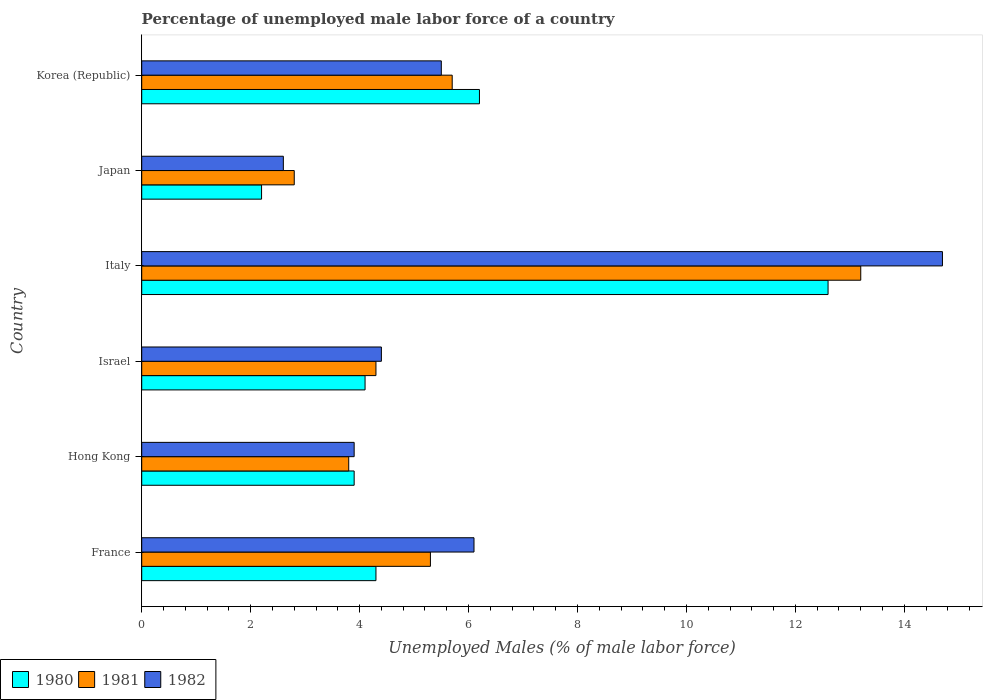How many groups of bars are there?
Offer a terse response. 6. Are the number of bars per tick equal to the number of legend labels?
Your answer should be compact. Yes. Are the number of bars on each tick of the Y-axis equal?
Provide a succinct answer. Yes. How many bars are there on the 5th tick from the top?
Make the answer very short. 3. How many bars are there on the 4th tick from the bottom?
Provide a succinct answer. 3. What is the percentage of unemployed male labor force in 1982 in Hong Kong?
Provide a succinct answer. 3.9. Across all countries, what is the maximum percentage of unemployed male labor force in 1981?
Provide a succinct answer. 13.2. Across all countries, what is the minimum percentage of unemployed male labor force in 1982?
Give a very brief answer. 2.6. In which country was the percentage of unemployed male labor force in 1981 maximum?
Provide a short and direct response. Italy. In which country was the percentage of unemployed male labor force in 1982 minimum?
Give a very brief answer. Japan. What is the total percentage of unemployed male labor force in 1980 in the graph?
Keep it short and to the point. 33.3. What is the difference between the percentage of unemployed male labor force in 1981 in Hong Kong and that in Japan?
Give a very brief answer. 1. What is the difference between the percentage of unemployed male labor force in 1982 in Israel and the percentage of unemployed male labor force in 1980 in Japan?
Offer a terse response. 2.2. What is the average percentage of unemployed male labor force in 1982 per country?
Ensure brevity in your answer.  6.2. What is the difference between the percentage of unemployed male labor force in 1980 and percentage of unemployed male labor force in 1981 in Hong Kong?
Your response must be concise. 0.1. What is the ratio of the percentage of unemployed male labor force in 1981 in Hong Kong to that in Italy?
Provide a succinct answer. 0.29. Is the percentage of unemployed male labor force in 1981 in Israel less than that in Italy?
Keep it short and to the point. Yes. Is the difference between the percentage of unemployed male labor force in 1980 in Hong Kong and Italy greater than the difference between the percentage of unemployed male labor force in 1981 in Hong Kong and Italy?
Your answer should be very brief. Yes. What is the difference between the highest and the second highest percentage of unemployed male labor force in 1980?
Keep it short and to the point. 6.4. What is the difference between the highest and the lowest percentage of unemployed male labor force in 1980?
Ensure brevity in your answer.  10.4. In how many countries, is the percentage of unemployed male labor force in 1980 greater than the average percentage of unemployed male labor force in 1980 taken over all countries?
Give a very brief answer. 2. Is the sum of the percentage of unemployed male labor force in 1981 in France and Israel greater than the maximum percentage of unemployed male labor force in 1982 across all countries?
Provide a short and direct response. No. What does the 1st bar from the bottom in Italy represents?
Your answer should be very brief. 1980. How many bars are there?
Ensure brevity in your answer.  18. What is the difference between two consecutive major ticks on the X-axis?
Keep it short and to the point. 2. Are the values on the major ticks of X-axis written in scientific E-notation?
Give a very brief answer. No. Does the graph contain any zero values?
Keep it short and to the point. No. Where does the legend appear in the graph?
Provide a short and direct response. Bottom left. What is the title of the graph?
Provide a succinct answer. Percentage of unemployed male labor force of a country. Does "1975" appear as one of the legend labels in the graph?
Ensure brevity in your answer.  No. What is the label or title of the X-axis?
Provide a succinct answer. Unemployed Males (% of male labor force). What is the Unemployed Males (% of male labor force) in 1980 in France?
Offer a terse response. 4.3. What is the Unemployed Males (% of male labor force) of 1981 in France?
Provide a succinct answer. 5.3. What is the Unemployed Males (% of male labor force) in 1982 in France?
Keep it short and to the point. 6.1. What is the Unemployed Males (% of male labor force) of 1980 in Hong Kong?
Your answer should be compact. 3.9. What is the Unemployed Males (% of male labor force) in 1981 in Hong Kong?
Ensure brevity in your answer.  3.8. What is the Unemployed Males (% of male labor force) of 1982 in Hong Kong?
Keep it short and to the point. 3.9. What is the Unemployed Males (% of male labor force) of 1980 in Israel?
Provide a short and direct response. 4.1. What is the Unemployed Males (% of male labor force) in 1981 in Israel?
Your answer should be compact. 4.3. What is the Unemployed Males (% of male labor force) of 1982 in Israel?
Offer a very short reply. 4.4. What is the Unemployed Males (% of male labor force) of 1980 in Italy?
Your answer should be compact. 12.6. What is the Unemployed Males (% of male labor force) of 1981 in Italy?
Provide a succinct answer. 13.2. What is the Unemployed Males (% of male labor force) of 1982 in Italy?
Provide a short and direct response. 14.7. What is the Unemployed Males (% of male labor force) in 1980 in Japan?
Your response must be concise. 2.2. What is the Unemployed Males (% of male labor force) of 1981 in Japan?
Your response must be concise. 2.8. What is the Unemployed Males (% of male labor force) in 1982 in Japan?
Provide a short and direct response. 2.6. What is the Unemployed Males (% of male labor force) of 1980 in Korea (Republic)?
Ensure brevity in your answer.  6.2. What is the Unemployed Males (% of male labor force) of 1981 in Korea (Republic)?
Keep it short and to the point. 5.7. What is the Unemployed Males (% of male labor force) in 1982 in Korea (Republic)?
Ensure brevity in your answer.  5.5. Across all countries, what is the maximum Unemployed Males (% of male labor force) of 1980?
Keep it short and to the point. 12.6. Across all countries, what is the maximum Unemployed Males (% of male labor force) in 1981?
Your answer should be compact. 13.2. Across all countries, what is the maximum Unemployed Males (% of male labor force) of 1982?
Your answer should be compact. 14.7. Across all countries, what is the minimum Unemployed Males (% of male labor force) in 1980?
Provide a short and direct response. 2.2. Across all countries, what is the minimum Unemployed Males (% of male labor force) of 1981?
Your answer should be compact. 2.8. Across all countries, what is the minimum Unemployed Males (% of male labor force) in 1982?
Give a very brief answer. 2.6. What is the total Unemployed Males (% of male labor force) of 1980 in the graph?
Ensure brevity in your answer.  33.3. What is the total Unemployed Males (% of male labor force) of 1981 in the graph?
Offer a terse response. 35.1. What is the total Unemployed Males (% of male labor force) of 1982 in the graph?
Your answer should be compact. 37.2. What is the difference between the Unemployed Males (% of male labor force) in 1981 in France and that in Israel?
Your answer should be very brief. 1. What is the difference between the Unemployed Males (% of male labor force) in 1982 in France and that in Israel?
Provide a succinct answer. 1.7. What is the difference between the Unemployed Males (% of male labor force) in 1980 in France and that in Italy?
Your response must be concise. -8.3. What is the difference between the Unemployed Males (% of male labor force) of 1980 in France and that in Japan?
Ensure brevity in your answer.  2.1. What is the difference between the Unemployed Males (% of male labor force) of 1982 in France and that in Korea (Republic)?
Offer a terse response. 0.6. What is the difference between the Unemployed Males (% of male labor force) in 1981 in Hong Kong and that in Israel?
Your answer should be compact. -0.5. What is the difference between the Unemployed Males (% of male labor force) of 1982 in Hong Kong and that in Italy?
Offer a terse response. -10.8. What is the difference between the Unemployed Males (% of male labor force) in 1980 in Hong Kong and that in Japan?
Make the answer very short. 1.7. What is the difference between the Unemployed Males (% of male labor force) of 1981 in Hong Kong and that in Japan?
Ensure brevity in your answer.  1. What is the difference between the Unemployed Males (% of male labor force) in 1982 in Hong Kong and that in Japan?
Offer a terse response. 1.3. What is the difference between the Unemployed Males (% of male labor force) in 1980 in Hong Kong and that in Korea (Republic)?
Provide a short and direct response. -2.3. What is the difference between the Unemployed Males (% of male labor force) in 1980 in Israel and that in Italy?
Your answer should be compact. -8.5. What is the difference between the Unemployed Males (% of male labor force) of 1981 in Israel and that in Italy?
Ensure brevity in your answer.  -8.9. What is the difference between the Unemployed Males (% of male labor force) of 1982 in Israel and that in Japan?
Keep it short and to the point. 1.8. What is the difference between the Unemployed Males (% of male labor force) in 1982 in Israel and that in Korea (Republic)?
Your response must be concise. -1.1. What is the difference between the Unemployed Males (% of male labor force) of 1982 in Italy and that in Japan?
Your answer should be compact. 12.1. What is the difference between the Unemployed Males (% of male labor force) of 1980 in Italy and that in Korea (Republic)?
Provide a short and direct response. 6.4. What is the difference between the Unemployed Males (% of male labor force) in 1982 in Italy and that in Korea (Republic)?
Offer a very short reply. 9.2. What is the difference between the Unemployed Males (% of male labor force) of 1981 in Japan and that in Korea (Republic)?
Provide a succinct answer. -2.9. What is the difference between the Unemployed Males (% of male labor force) of 1980 in France and the Unemployed Males (% of male labor force) of 1982 in Hong Kong?
Your response must be concise. 0.4. What is the difference between the Unemployed Males (% of male labor force) in 1980 in France and the Unemployed Males (% of male labor force) in 1981 in Israel?
Make the answer very short. 0. What is the difference between the Unemployed Males (% of male labor force) in 1981 in France and the Unemployed Males (% of male labor force) in 1982 in Israel?
Your answer should be compact. 0.9. What is the difference between the Unemployed Males (% of male labor force) in 1980 in France and the Unemployed Males (% of male labor force) in 1981 in Italy?
Ensure brevity in your answer.  -8.9. What is the difference between the Unemployed Males (% of male labor force) of 1981 in France and the Unemployed Males (% of male labor force) of 1982 in Italy?
Make the answer very short. -9.4. What is the difference between the Unemployed Males (% of male labor force) of 1980 in France and the Unemployed Males (% of male labor force) of 1982 in Japan?
Keep it short and to the point. 1.7. What is the difference between the Unemployed Males (% of male labor force) of 1981 in France and the Unemployed Males (% of male labor force) of 1982 in Japan?
Ensure brevity in your answer.  2.7. What is the difference between the Unemployed Males (% of male labor force) in 1980 in France and the Unemployed Males (% of male labor force) in 1982 in Korea (Republic)?
Give a very brief answer. -1.2. What is the difference between the Unemployed Males (% of male labor force) of 1981 in France and the Unemployed Males (% of male labor force) of 1982 in Korea (Republic)?
Your answer should be compact. -0.2. What is the difference between the Unemployed Males (% of male labor force) of 1980 in Hong Kong and the Unemployed Males (% of male labor force) of 1981 in Israel?
Offer a terse response. -0.4. What is the difference between the Unemployed Males (% of male labor force) in 1980 in Hong Kong and the Unemployed Males (% of male labor force) in 1981 in Italy?
Give a very brief answer. -9.3. What is the difference between the Unemployed Males (% of male labor force) of 1980 in Hong Kong and the Unemployed Males (% of male labor force) of 1982 in Italy?
Give a very brief answer. -10.8. What is the difference between the Unemployed Males (% of male labor force) in 1981 in Hong Kong and the Unemployed Males (% of male labor force) in 1982 in Italy?
Offer a very short reply. -10.9. What is the difference between the Unemployed Males (% of male labor force) of 1980 in Hong Kong and the Unemployed Males (% of male labor force) of 1982 in Japan?
Offer a very short reply. 1.3. What is the difference between the Unemployed Males (% of male labor force) in 1981 in Hong Kong and the Unemployed Males (% of male labor force) in 1982 in Japan?
Offer a terse response. 1.2. What is the difference between the Unemployed Males (% of male labor force) of 1980 in Hong Kong and the Unemployed Males (% of male labor force) of 1981 in Korea (Republic)?
Offer a very short reply. -1.8. What is the difference between the Unemployed Males (% of male labor force) in 1980 in Israel and the Unemployed Males (% of male labor force) in 1981 in Italy?
Keep it short and to the point. -9.1. What is the difference between the Unemployed Males (% of male labor force) of 1980 in Israel and the Unemployed Males (% of male labor force) of 1981 in Japan?
Your response must be concise. 1.3. What is the difference between the Unemployed Males (% of male labor force) of 1981 in Israel and the Unemployed Males (% of male labor force) of 1982 in Japan?
Your answer should be very brief. 1.7. What is the difference between the Unemployed Males (% of male labor force) of 1980 in Israel and the Unemployed Males (% of male labor force) of 1981 in Korea (Republic)?
Give a very brief answer. -1.6. What is the difference between the Unemployed Males (% of male labor force) of 1981 in Italy and the Unemployed Males (% of male labor force) of 1982 in Japan?
Give a very brief answer. 10.6. What is the difference between the Unemployed Males (% of male labor force) in 1980 in Italy and the Unemployed Males (% of male labor force) in 1982 in Korea (Republic)?
Keep it short and to the point. 7.1. What is the difference between the Unemployed Males (% of male labor force) of 1981 in Italy and the Unemployed Males (% of male labor force) of 1982 in Korea (Republic)?
Give a very brief answer. 7.7. What is the difference between the Unemployed Males (% of male labor force) in 1980 in Japan and the Unemployed Males (% of male labor force) in 1982 in Korea (Republic)?
Ensure brevity in your answer.  -3.3. What is the average Unemployed Males (% of male labor force) in 1980 per country?
Offer a terse response. 5.55. What is the average Unemployed Males (% of male labor force) of 1981 per country?
Your answer should be compact. 5.85. What is the average Unemployed Males (% of male labor force) of 1982 per country?
Provide a short and direct response. 6.2. What is the difference between the Unemployed Males (% of male labor force) in 1981 and Unemployed Males (% of male labor force) in 1982 in France?
Provide a short and direct response. -0.8. What is the difference between the Unemployed Males (% of male labor force) of 1980 and Unemployed Males (% of male labor force) of 1981 in Hong Kong?
Offer a very short reply. 0.1. What is the difference between the Unemployed Males (% of male labor force) of 1980 and Unemployed Males (% of male labor force) of 1981 in Israel?
Keep it short and to the point. -0.2. What is the difference between the Unemployed Males (% of male labor force) of 1981 and Unemployed Males (% of male labor force) of 1982 in Israel?
Keep it short and to the point. -0.1. What is the difference between the Unemployed Males (% of male labor force) of 1980 and Unemployed Males (% of male labor force) of 1981 in Italy?
Your answer should be very brief. -0.6. What is the difference between the Unemployed Males (% of male labor force) of 1980 and Unemployed Males (% of male labor force) of 1982 in Italy?
Give a very brief answer. -2.1. What is the difference between the Unemployed Males (% of male labor force) of 1980 and Unemployed Males (% of male labor force) of 1981 in Japan?
Offer a very short reply. -0.6. What is the difference between the Unemployed Males (% of male labor force) in 1980 and Unemployed Males (% of male labor force) in 1982 in Japan?
Ensure brevity in your answer.  -0.4. What is the difference between the Unemployed Males (% of male labor force) in 1981 and Unemployed Males (% of male labor force) in 1982 in Japan?
Provide a short and direct response. 0.2. What is the difference between the Unemployed Males (% of male labor force) of 1980 and Unemployed Males (% of male labor force) of 1982 in Korea (Republic)?
Ensure brevity in your answer.  0.7. What is the ratio of the Unemployed Males (% of male labor force) of 1980 in France to that in Hong Kong?
Give a very brief answer. 1.1. What is the ratio of the Unemployed Males (% of male labor force) in 1981 in France to that in Hong Kong?
Your answer should be compact. 1.39. What is the ratio of the Unemployed Males (% of male labor force) in 1982 in France to that in Hong Kong?
Offer a very short reply. 1.56. What is the ratio of the Unemployed Males (% of male labor force) of 1980 in France to that in Israel?
Give a very brief answer. 1.05. What is the ratio of the Unemployed Males (% of male labor force) in 1981 in France to that in Israel?
Provide a short and direct response. 1.23. What is the ratio of the Unemployed Males (% of male labor force) in 1982 in France to that in Israel?
Offer a terse response. 1.39. What is the ratio of the Unemployed Males (% of male labor force) in 1980 in France to that in Italy?
Provide a short and direct response. 0.34. What is the ratio of the Unemployed Males (% of male labor force) of 1981 in France to that in Italy?
Your answer should be very brief. 0.4. What is the ratio of the Unemployed Males (% of male labor force) of 1982 in France to that in Italy?
Make the answer very short. 0.41. What is the ratio of the Unemployed Males (% of male labor force) in 1980 in France to that in Japan?
Your answer should be very brief. 1.95. What is the ratio of the Unemployed Males (% of male labor force) in 1981 in France to that in Japan?
Your response must be concise. 1.89. What is the ratio of the Unemployed Males (% of male labor force) of 1982 in France to that in Japan?
Provide a short and direct response. 2.35. What is the ratio of the Unemployed Males (% of male labor force) in 1980 in France to that in Korea (Republic)?
Provide a succinct answer. 0.69. What is the ratio of the Unemployed Males (% of male labor force) in 1981 in France to that in Korea (Republic)?
Make the answer very short. 0.93. What is the ratio of the Unemployed Males (% of male labor force) of 1982 in France to that in Korea (Republic)?
Your answer should be very brief. 1.11. What is the ratio of the Unemployed Males (% of male labor force) in 1980 in Hong Kong to that in Israel?
Give a very brief answer. 0.95. What is the ratio of the Unemployed Males (% of male labor force) in 1981 in Hong Kong to that in Israel?
Provide a short and direct response. 0.88. What is the ratio of the Unemployed Males (% of male labor force) in 1982 in Hong Kong to that in Israel?
Provide a succinct answer. 0.89. What is the ratio of the Unemployed Males (% of male labor force) in 1980 in Hong Kong to that in Italy?
Offer a terse response. 0.31. What is the ratio of the Unemployed Males (% of male labor force) in 1981 in Hong Kong to that in Italy?
Provide a short and direct response. 0.29. What is the ratio of the Unemployed Males (% of male labor force) in 1982 in Hong Kong to that in Italy?
Keep it short and to the point. 0.27. What is the ratio of the Unemployed Males (% of male labor force) in 1980 in Hong Kong to that in Japan?
Your answer should be compact. 1.77. What is the ratio of the Unemployed Males (% of male labor force) of 1981 in Hong Kong to that in Japan?
Make the answer very short. 1.36. What is the ratio of the Unemployed Males (% of male labor force) in 1982 in Hong Kong to that in Japan?
Offer a very short reply. 1.5. What is the ratio of the Unemployed Males (% of male labor force) in 1980 in Hong Kong to that in Korea (Republic)?
Provide a succinct answer. 0.63. What is the ratio of the Unemployed Males (% of male labor force) of 1982 in Hong Kong to that in Korea (Republic)?
Keep it short and to the point. 0.71. What is the ratio of the Unemployed Males (% of male labor force) in 1980 in Israel to that in Italy?
Give a very brief answer. 0.33. What is the ratio of the Unemployed Males (% of male labor force) of 1981 in Israel to that in Italy?
Offer a very short reply. 0.33. What is the ratio of the Unemployed Males (% of male labor force) in 1982 in Israel to that in Italy?
Give a very brief answer. 0.3. What is the ratio of the Unemployed Males (% of male labor force) of 1980 in Israel to that in Japan?
Offer a very short reply. 1.86. What is the ratio of the Unemployed Males (% of male labor force) in 1981 in Israel to that in Japan?
Your response must be concise. 1.54. What is the ratio of the Unemployed Males (% of male labor force) of 1982 in Israel to that in Japan?
Keep it short and to the point. 1.69. What is the ratio of the Unemployed Males (% of male labor force) of 1980 in Israel to that in Korea (Republic)?
Offer a very short reply. 0.66. What is the ratio of the Unemployed Males (% of male labor force) in 1981 in Israel to that in Korea (Republic)?
Make the answer very short. 0.75. What is the ratio of the Unemployed Males (% of male labor force) in 1982 in Israel to that in Korea (Republic)?
Your answer should be very brief. 0.8. What is the ratio of the Unemployed Males (% of male labor force) of 1980 in Italy to that in Japan?
Your response must be concise. 5.73. What is the ratio of the Unemployed Males (% of male labor force) of 1981 in Italy to that in Japan?
Your answer should be very brief. 4.71. What is the ratio of the Unemployed Males (% of male labor force) in 1982 in Italy to that in Japan?
Your response must be concise. 5.65. What is the ratio of the Unemployed Males (% of male labor force) in 1980 in Italy to that in Korea (Republic)?
Your answer should be compact. 2.03. What is the ratio of the Unemployed Males (% of male labor force) of 1981 in Italy to that in Korea (Republic)?
Provide a succinct answer. 2.32. What is the ratio of the Unemployed Males (% of male labor force) in 1982 in Italy to that in Korea (Republic)?
Ensure brevity in your answer.  2.67. What is the ratio of the Unemployed Males (% of male labor force) in 1980 in Japan to that in Korea (Republic)?
Ensure brevity in your answer.  0.35. What is the ratio of the Unemployed Males (% of male labor force) of 1981 in Japan to that in Korea (Republic)?
Your answer should be compact. 0.49. What is the ratio of the Unemployed Males (% of male labor force) in 1982 in Japan to that in Korea (Republic)?
Your response must be concise. 0.47. What is the difference between the highest and the second highest Unemployed Males (% of male labor force) of 1981?
Your answer should be very brief. 7.5. What is the difference between the highest and the second highest Unemployed Males (% of male labor force) in 1982?
Offer a very short reply. 8.6. 